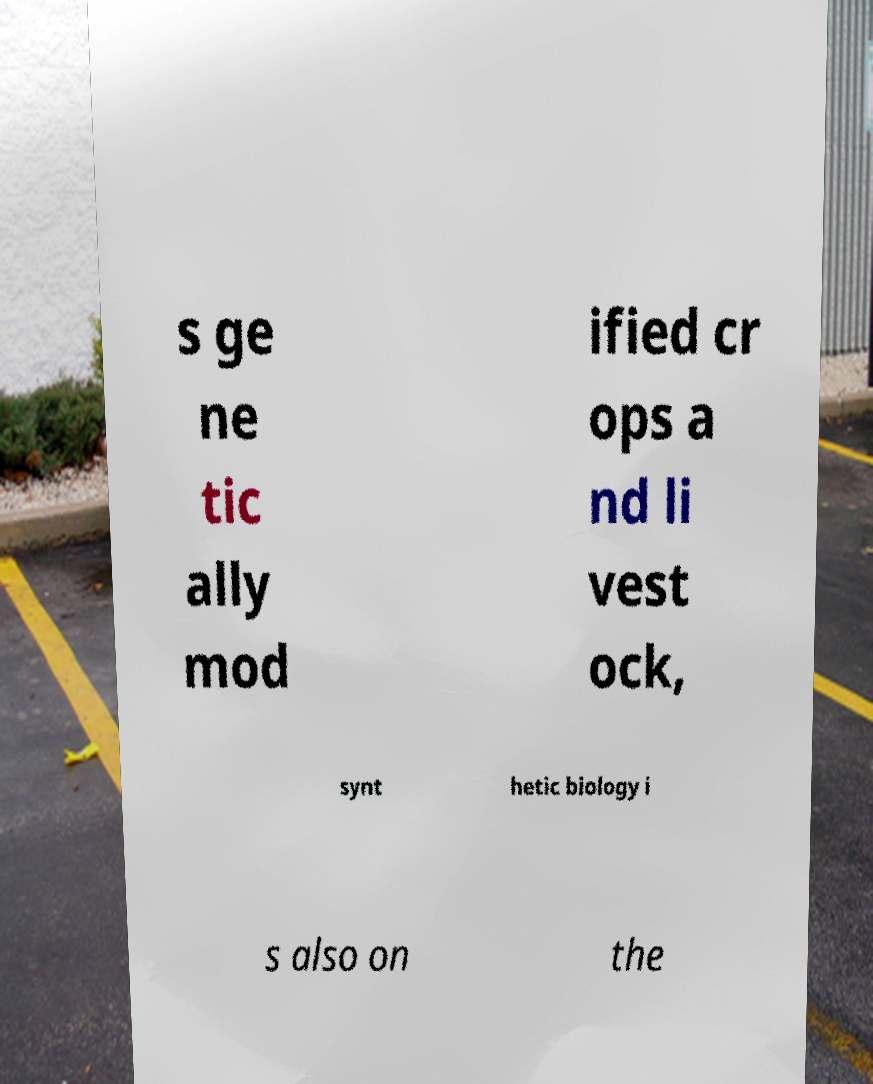Could you extract and type out the text from this image? s ge ne tic ally mod ified cr ops a nd li vest ock, synt hetic biology i s also on the 